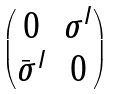<formula> <loc_0><loc_0><loc_500><loc_500>\begin{pmatrix} 0 & \sigma ^ { I } \\ \bar { \sigma } ^ { I } & 0 \end{pmatrix}</formula> 